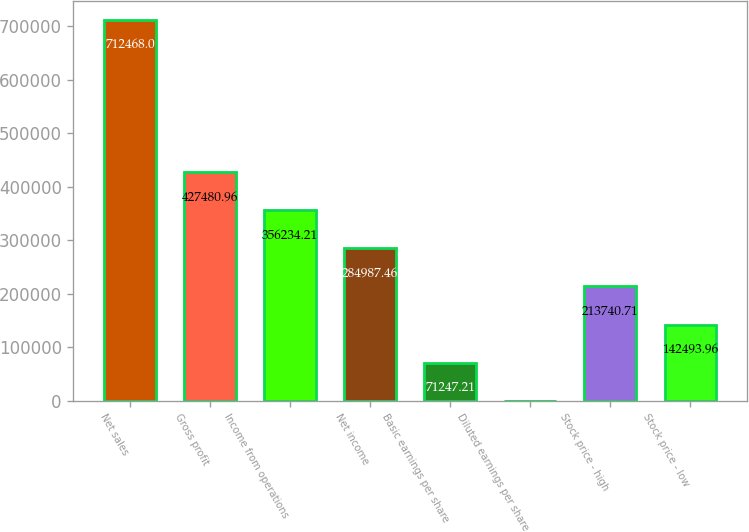<chart> <loc_0><loc_0><loc_500><loc_500><bar_chart><fcel>Net sales<fcel>Gross profit<fcel>Income from operations<fcel>Net income<fcel>Basic earnings per share<fcel>Diluted earnings per share<fcel>Stock price - high<fcel>Stock price - low<nl><fcel>712468<fcel>427481<fcel>356234<fcel>284987<fcel>71247.2<fcel>0.46<fcel>213741<fcel>142494<nl></chart> 